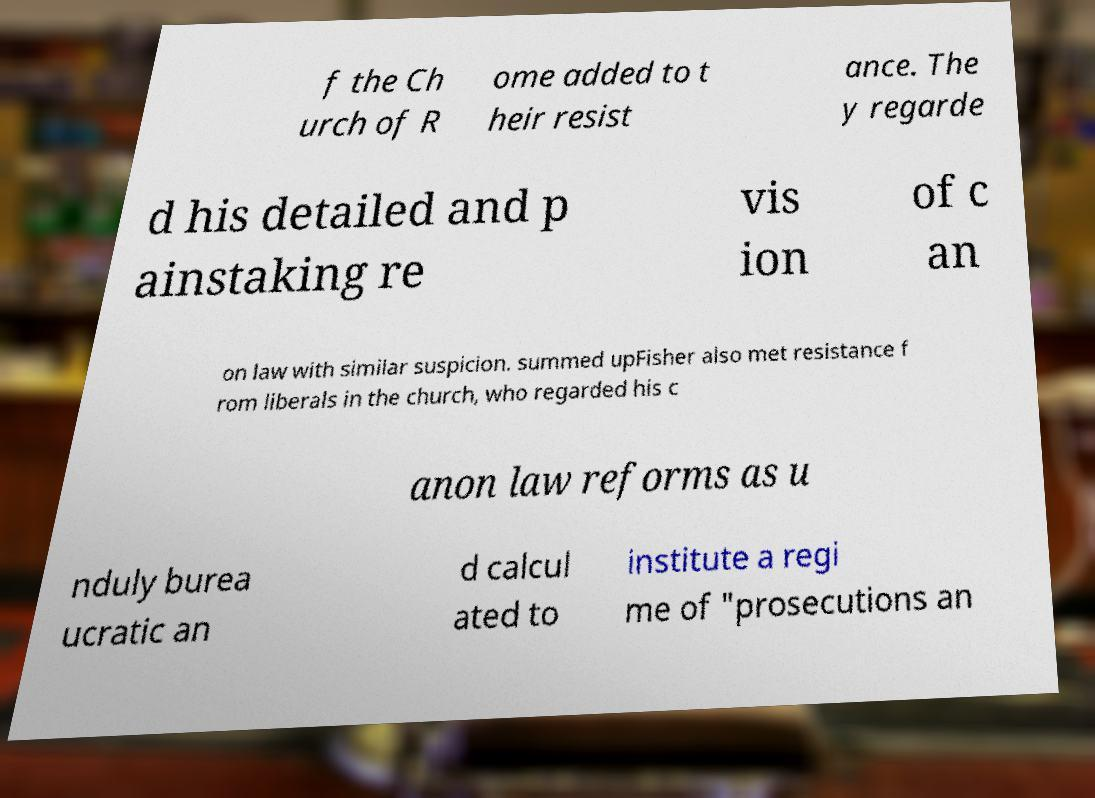Can you accurately transcribe the text from the provided image for me? f the Ch urch of R ome added to t heir resist ance. The y regarde d his detailed and p ainstaking re vis ion of c an on law with similar suspicion. summed upFisher also met resistance f rom liberals in the church, who regarded his c anon law reforms as u nduly burea ucratic an d calcul ated to institute a regi me of "prosecutions an 